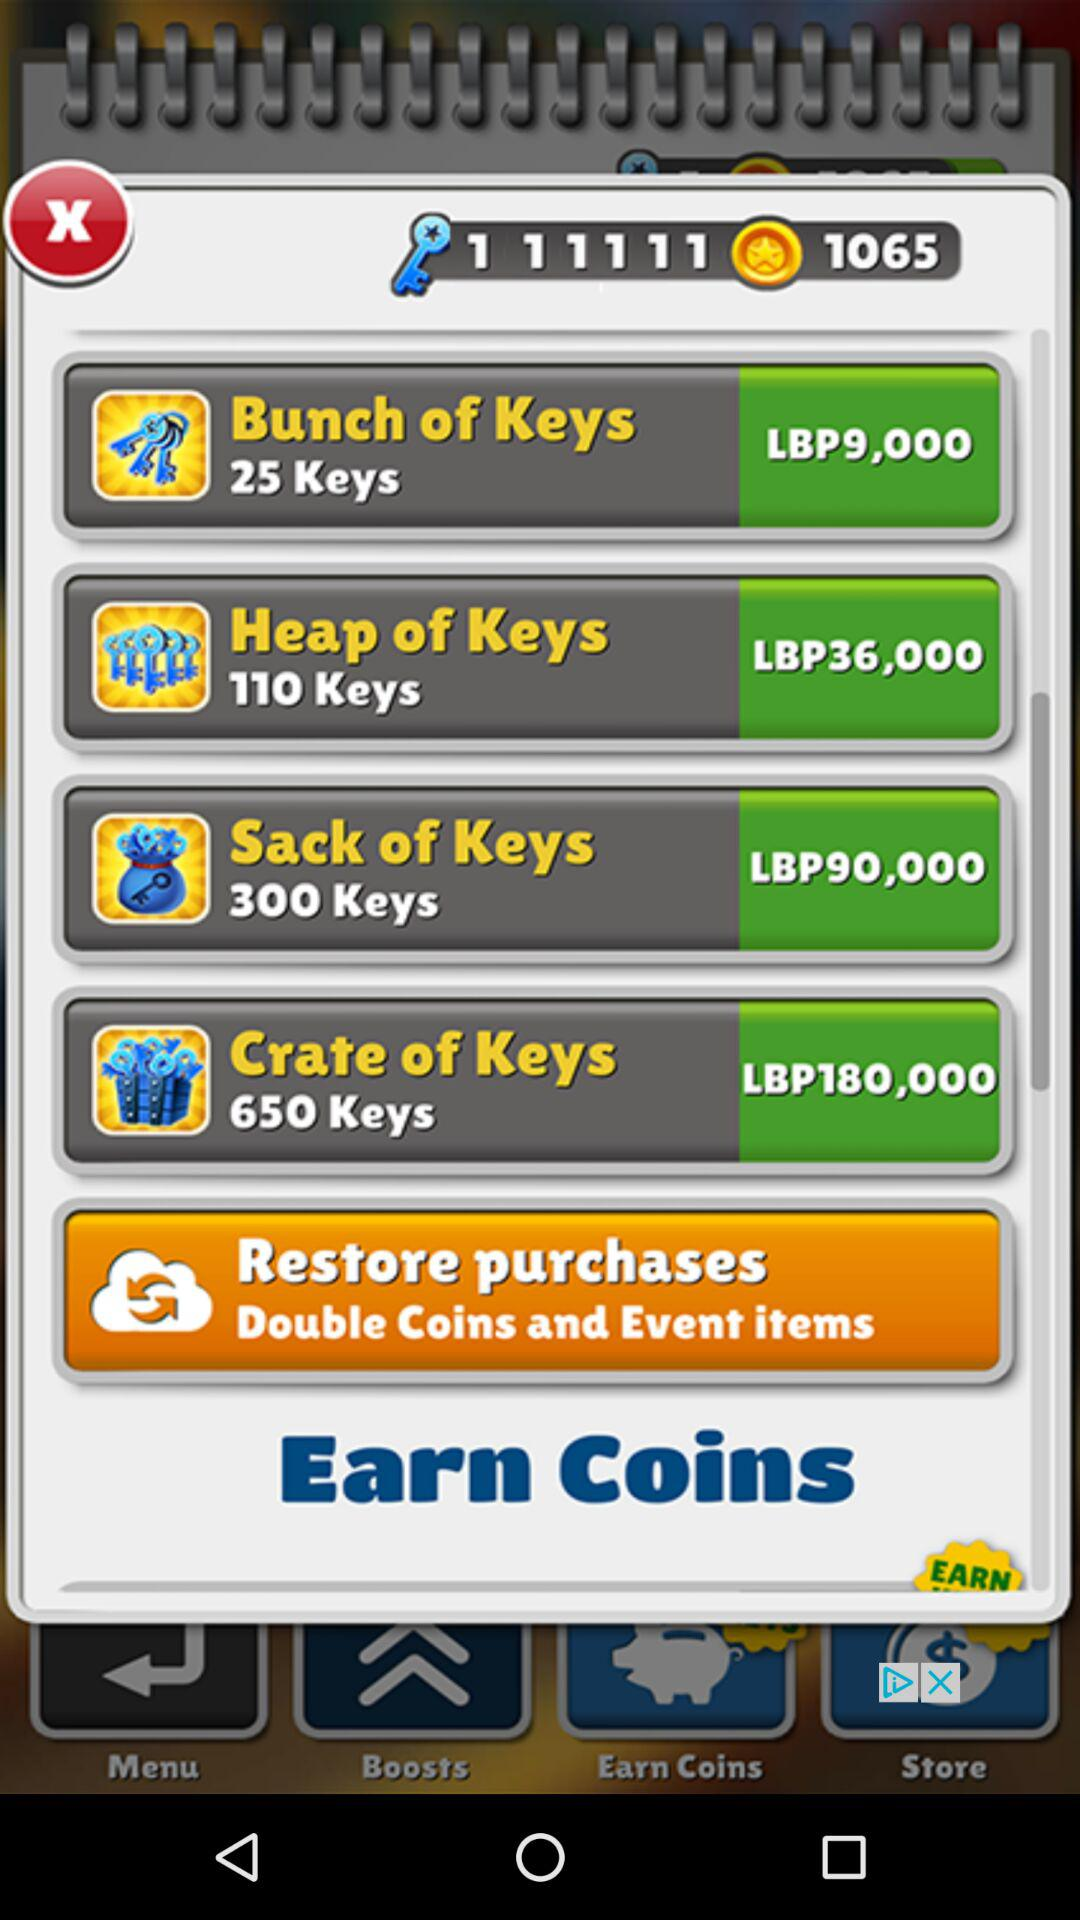How many keys correspond to ninety thousand LBP? There are 300 keys that correspond to ninety thousand LBP. 